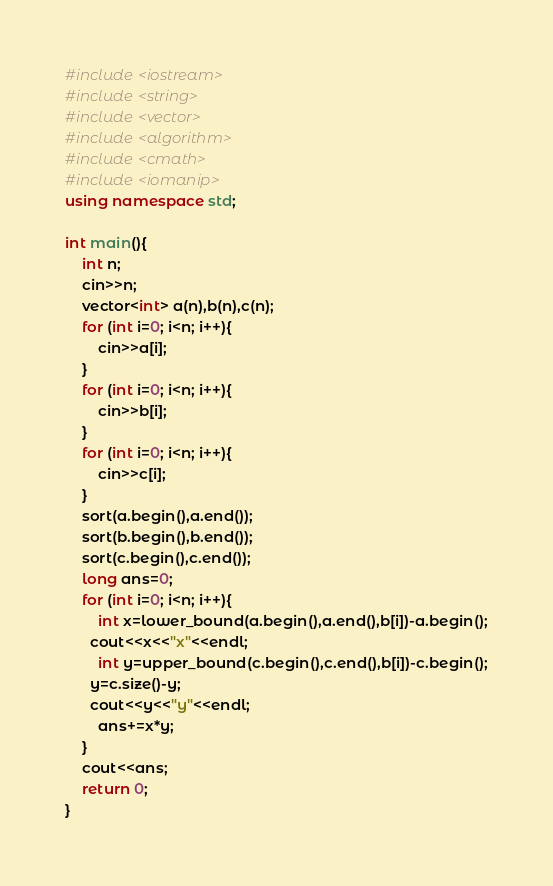<code> <loc_0><loc_0><loc_500><loc_500><_C++_>#include <iostream>
#include <string>
#include <vector>
#include <algorithm>
#include <cmath>
#include <iomanip>
using namespace std;
 
int main(){
    int n;
    cin>>n;
    vector<int> a(n),b(n),c(n);
    for (int i=0; i<n; i++){
        cin>>a[i];
    }
    for (int i=0; i<n; i++){
        cin>>b[i];
    }
    for (int i=0; i<n; i++){
        cin>>c[i];
    }
    sort(a.begin(),a.end());
    sort(b.begin(),b.end());
    sort(c.begin(),c.end());
    long ans=0;
    for (int i=0; i<n; i++){
        int x=lower_bound(a.begin(),a.end(),b[i])-a.begin();
      cout<<x<<"x"<<endl;
        int y=upper_bound(c.begin(),c.end(),b[i])-c.begin();
      y=c.size()-y;
      cout<<y<<"y"<<endl;
        ans+=x*y;
    }
    cout<<ans;
    return 0;
}</code> 